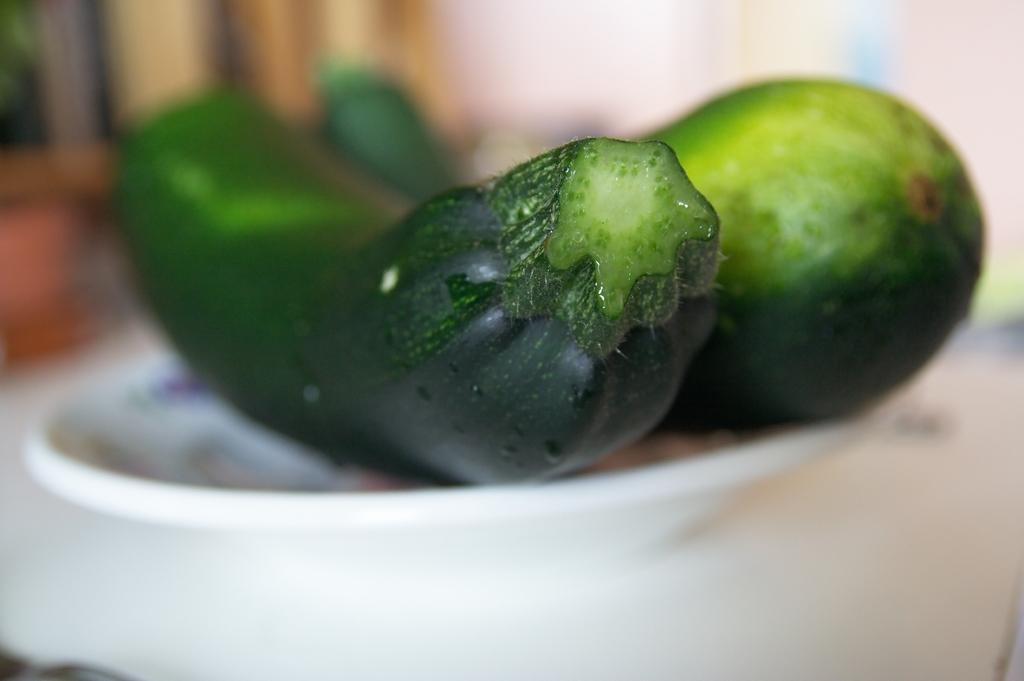What type of vegetable is present in the image? There are cucumbers in the image. How are the cucumbers arranged in the image? The cucumbers are in a bowl. What color is the bowl containing the cucumbers? The bowl is white. Can you describe the background of the image? The background of the image is blurred. What type of string is used to hold the cucumbers together in the image? There is no string present in the image; the cucumbers are in a bowl. 